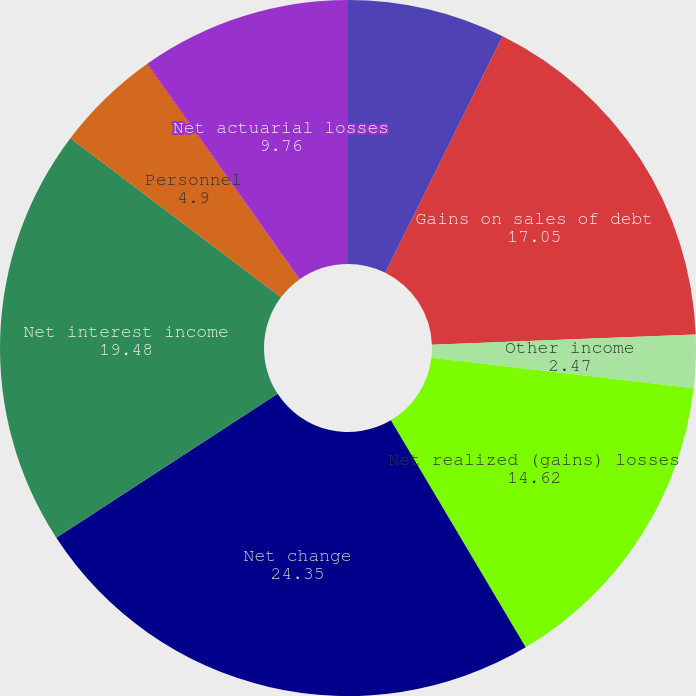<chart> <loc_0><loc_0><loc_500><loc_500><pie_chart><fcel>Net increase (decrease) in<fcel>Gains on sales of debt<fcel>Other income<fcel>Net realized (gains) losses<fcel>Net change<fcel>Net interest income<fcel>Personnel<fcel>Prior service cost<fcel>Net actuarial losses<nl><fcel>7.33%<fcel>17.05%<fcel>2.47%<fcel>14.62%<fcel>24.35%<fcel>19.48%<fcel>4.9%<fcel>0.04%<fcel>9.76%<nl></chart> 